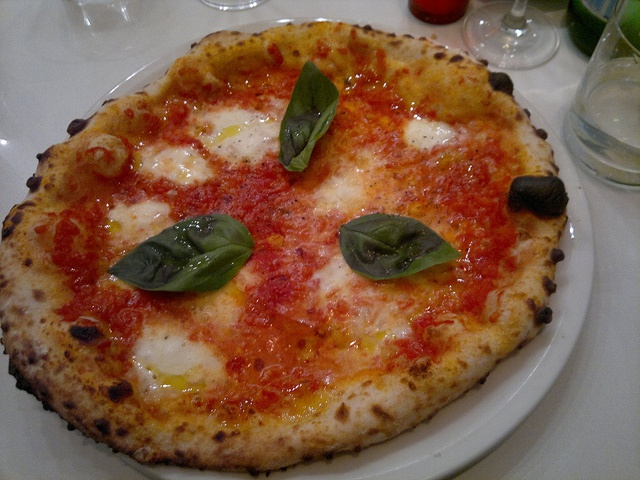Describe the objects in this image and their specific colors. I can see pizza in gray, brown, and maroon tones, dining table in gray and black tones, cup in gray and darkgreen tones, and wine glass in gray tones in this image. 